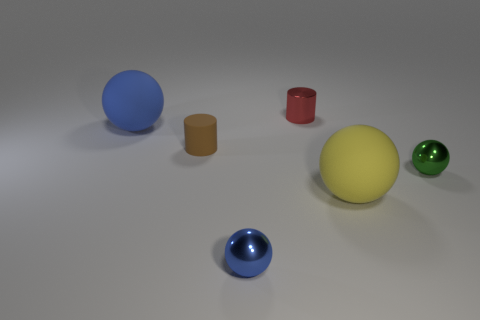Subtract all small blue metal balls. How many balls are left? 3 Subtract all red blocks. How many blue spheres are left? 2 Subtract all yellow spheres. How many spheres are left? 3 Subtract all gray spheres. Subtract all brown cylinders. How many spheres are left? 4 Add 2 big purple cylinders. How many objects exist? 8 Subtract all spheres. How many objects are left? 2 Subtract 1 green spheres. How many objects are left? 5 Subtract all cyan shiny cylinders. Subtract all large spheres. How many objects are left? 4 Add 2 brown rubber cylinders. How many brown rubber cylinders are left? 3 Add 1 rubber things. How many rubber things exist? 4 